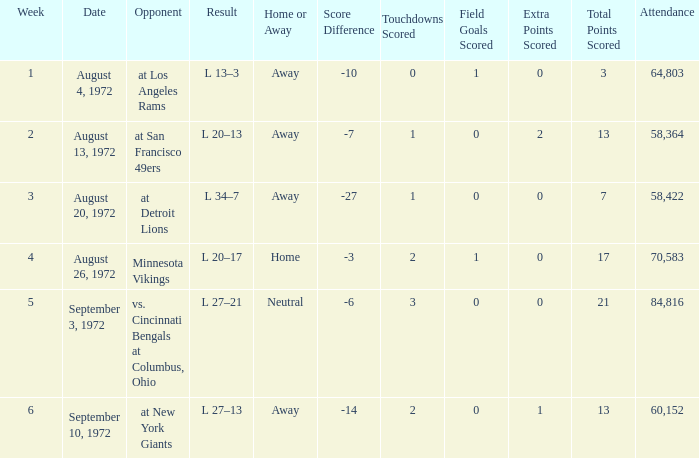How many weeks had an attendance larger than 84,816? 0.0. 